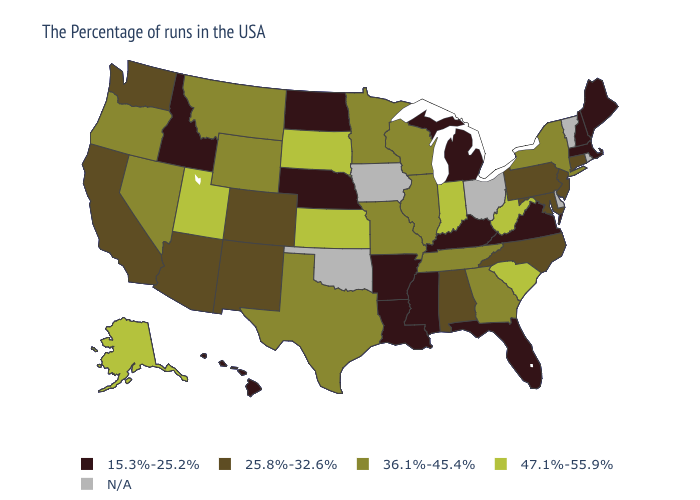How many symbols are there in the legend?
Quick response, please. 5. Does Wisconsin have the lowest value in the MidWest?
Quick response, please. No. What is the value of Mississippi?
Answer briefly. 15.3%-25.2%. Which states have the lowest value in the South?
Keep it brief. Virginia, Florida, Kentucky, Mississippi, Louisiana, Arkansas. Among the states that border West Virginia , does Kentucky have the highest value?
Answer briefly. No. What is the lowest value in the South?
Keep it brief. 15.3%-25.2%. What is the highest value in states that border Massachusetts?
Short answer required. 36.1%-45.4%. What is the value of Delaware?
Short answer required. N/A. What is the value of Kansas?
Write a very short answer. 47.1%-55.9%. Which states hav the highest value in the MidWest?
Concise answer only. Indiana, Kansas, South Dakota. Name the states that have a value in the range 47.1%-55.9%?
Concise answer only. South Carolina, West Virginia, Indiana, Kansas, South Dakota, Utah, Alaska. Does Maine have the lowest value in the USA?
Write a very short answer. Yes. What is the value of Hawaii?
Short answer required. 15.3%-25.2%. Name the states that have a value in the range N/A?
Write a very short answer. Rhode Island, Vermont, Delaware, Ohio, Iowa, Oklahoma. 